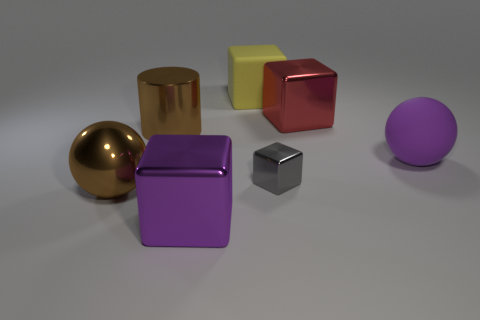Subtract 1 blocks. How many blocks are left? 3 Subtract all yellow spheres. Subtract all blue blocks. How many spheres are left? 2 Add 3 big blue matte objects. How many objects exist? 10 Subtract all cylinders. How many objects are left? 6 Subtract all large brown balls. Subtract all large green metal cylinders. How many objects are left? 6 Add 7 big purple blocks. How many big purple blocks are left? 8 Add 5 big balls. How many big balls exist? 7 Subtract 0 gray spheres. How many objects are left? 7 